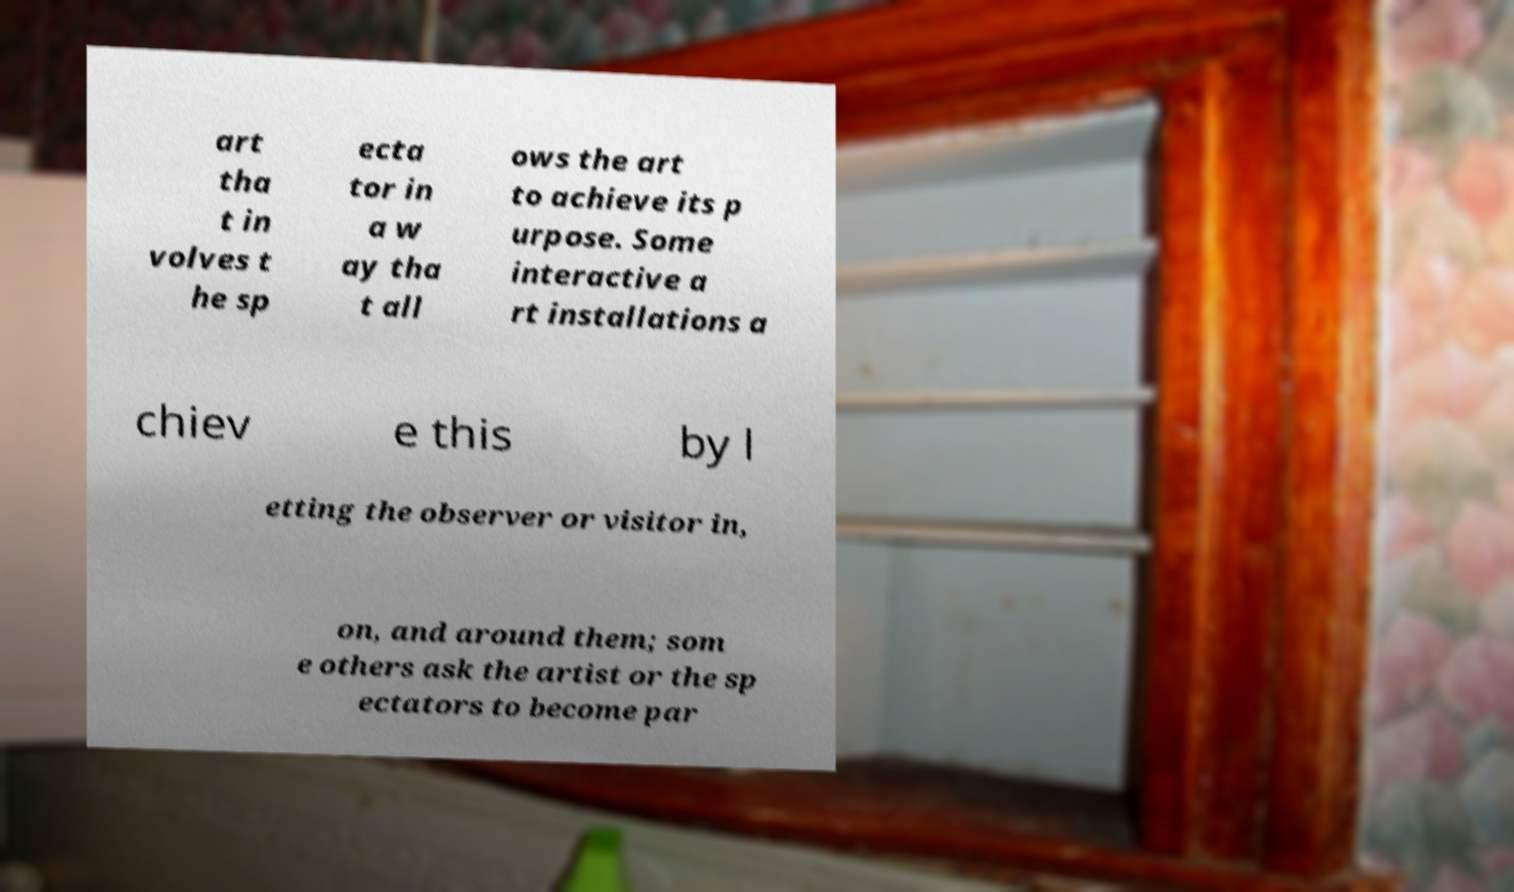There's text embedded in this image that I need extracted. Can you transcribe it verbatim? art tha t in volves t he sp ecta tor in a w ay tha t all ows the art to achieve its p urpose. Some interactive a rt installations a chiev e this by l etting the observer or visitor in, on, and around them; som e others ask the artist or the sp ectators to become par 